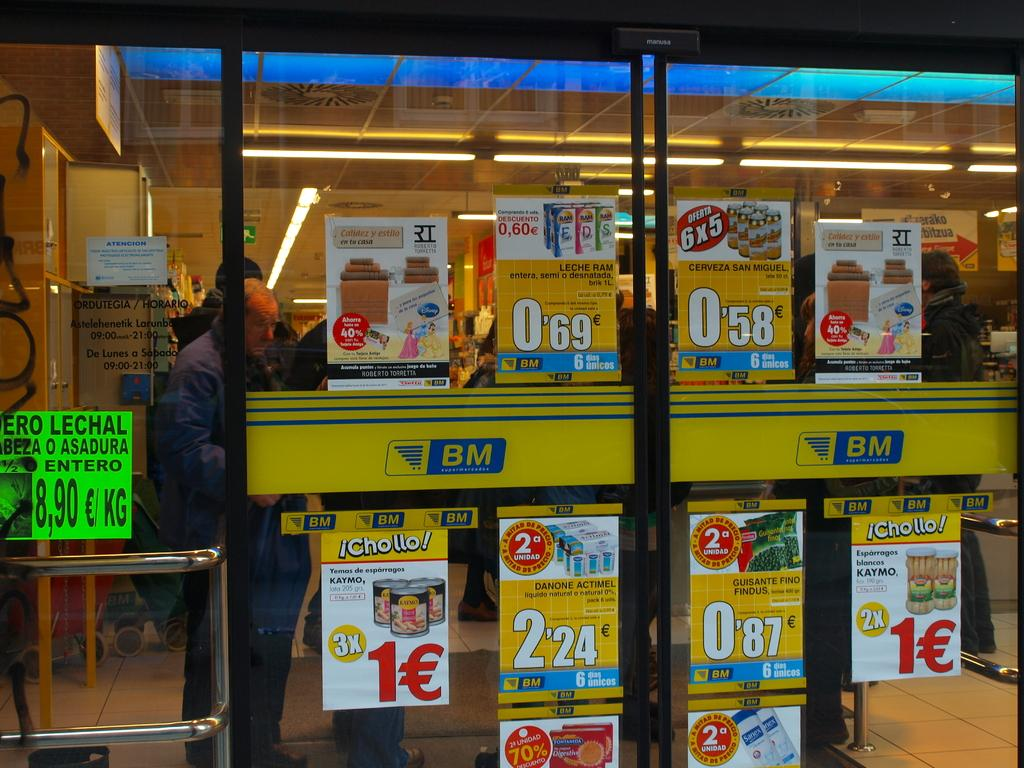Provide a one-sentence caption for the provided image. a lot of sales are going on at the store BM. 